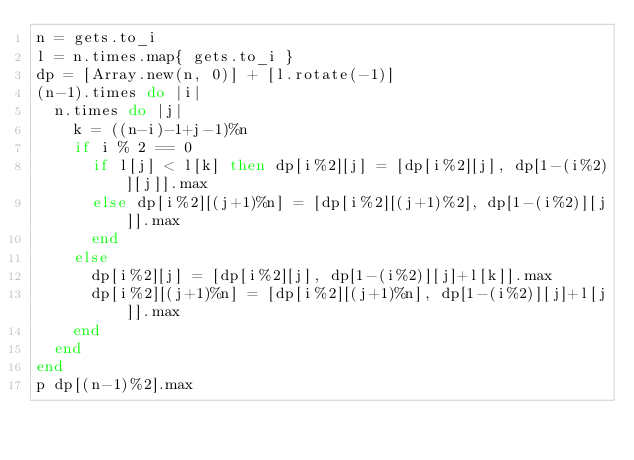<code> <loc_0><loc_0><loc_500><loc_500><_Ruby_>n = gets.to_i
l = n.times.map{ gets.to_i }
dp = [Array.new(n, 0)] + [l.rotate(-1)]
(n-1).times do |i|
  n.times do |j|
    k = ((n-i)-1+j-1)%n
    if i % 2 == 0
      if l[j] < l[k] then dp[i%2][j] = [dp[i%2][j], dp[1-(i%2)][j]].max
      else dp[i%2][(j+1)%n] = [dp[i%2][(j+1)%2], dp[1-(i%2)][j]].max
      end
    else
      dp[i%2][j] = [dp[i%2][j], dp[1-(i%2)][j]+l[k]].max
      dp[i%2][(j+1)%n] = [dp[i%2][(j+1)%n], dp[1-(i%2)][j]+l[j]].max
    end
  end
end
p dp[(n-1)%2].max</code> 